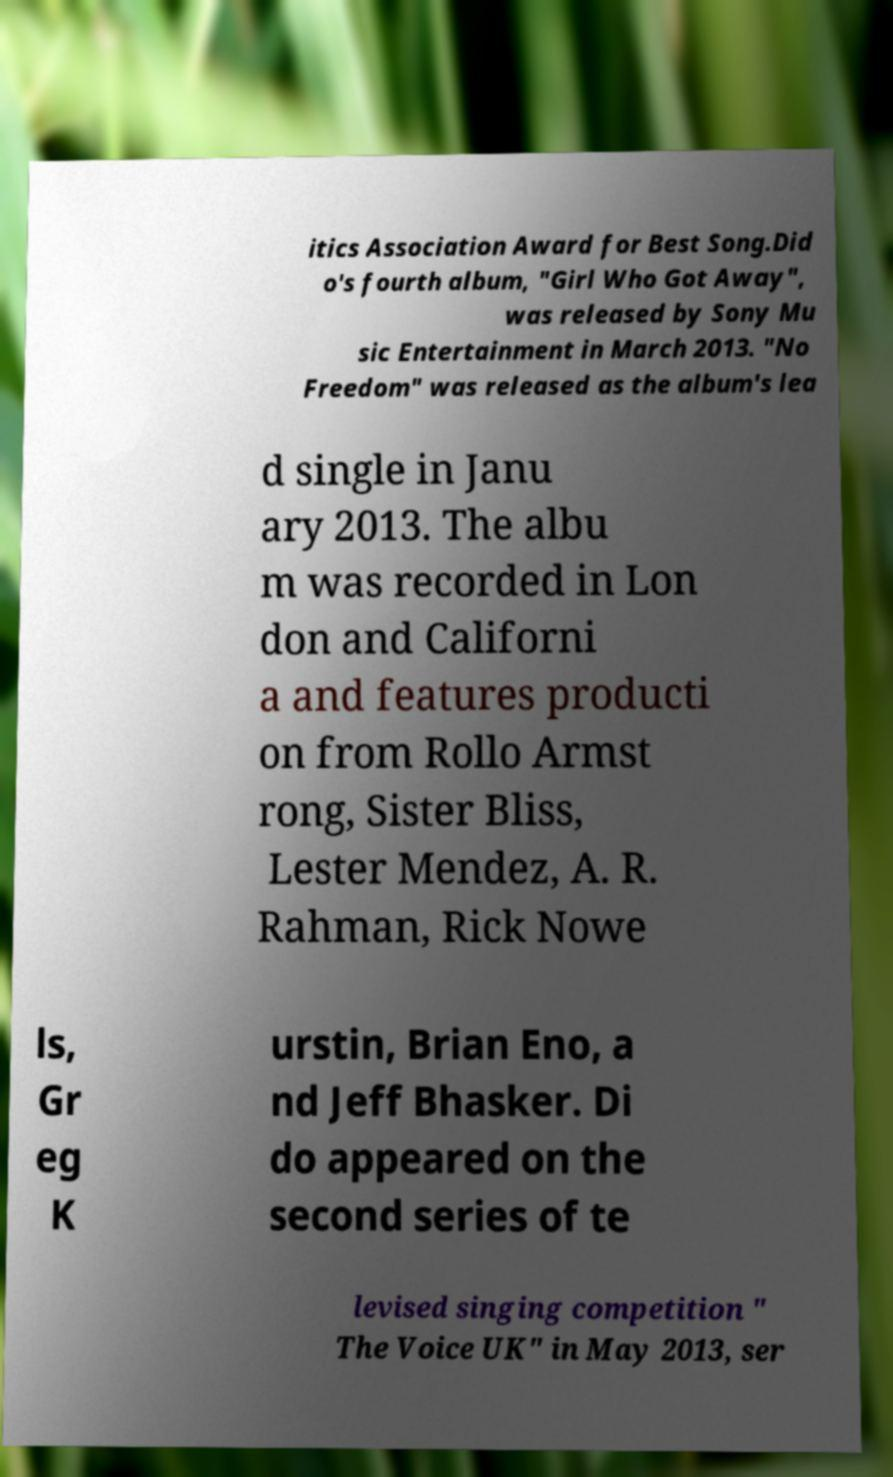Could you extract and type out the text from this image? itics Association Award for Best Song.Did o's fourth album, "Girl Who Got Away", was released by Sony Mu sic Entertainment in March 2013. "No Freedom" was released as the album's lea d single in Janu ary 2013. The albu m was recorded in Lon don and Californi a and features producti on from Rollo Armst rong, Sister Bliss, Lester Mendez, A. R. Rahman, Rick Nowe ls, Gr eg K urstin, Brian Eno, a nd Jeff Bhasker. Di do appeared on the second series of te levised singing competition " The Voice UK" in May 2013, ser 